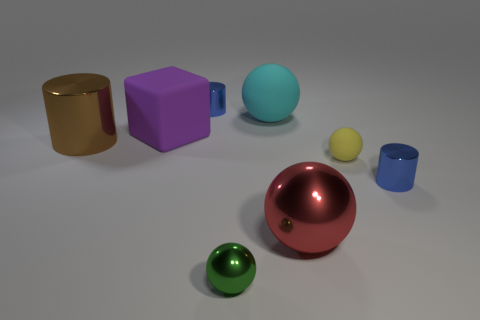There is a rubber object that is right of the big cyan ball; does it have the same shape as the brown thing?
Your answer should be compact. No. What is the shape of the big red shiny thing?
Your answer should be very brief. Sphere. How many large objects are the same material as the yellow ball?
Give a very brief answer. 2. Do the tiny matte thing and the metallic cylinder that is to the left of the purple object have the same color?
Offer a terse response. No. What number of tiny matte objects are there?
Provide a short and direct response. 1. Are there any small matte balls of the same color as the big cylinder?
Your answer should be compact. No. What color is the shiny cylinder that is on the right side of the blue cylinder that is to the left of the large rubber object that is to the right of the purple thing?
Ensure brevity in your answer.  Blue. Does the green thing have the same material as the tiny blue cylinder to the right of the tiny green metal thing?
Provide a succinct answer. Yes. What is the big brown object made of?
Give a very brief answer. Metal. How many other things are there of the same material as the red thing?
Offer a terse response. 4. 